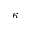<formula> <loc_0><loc_0><loc_500><loc_500>\kappa</formula> 